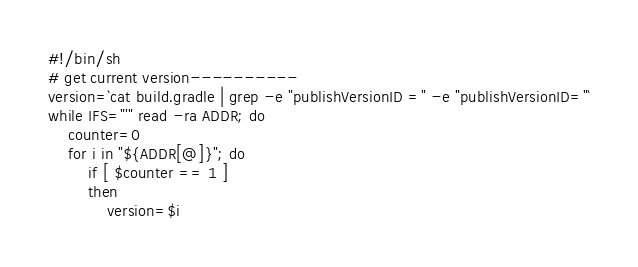<code> <loc_0><loc_0><loc_500><loc_500><_Bash_>#!/bin/sh
# get current version----------
version=`cat build.gradle | grep -e "publishVersionID =" -e "publishVersionID="`
while IFS="'" read -ra ADDR; do
    counter=0
    for i in "${ADDR[@]}"; do
        if [ $counter == 1 ]
        then
            version=$i</code> 